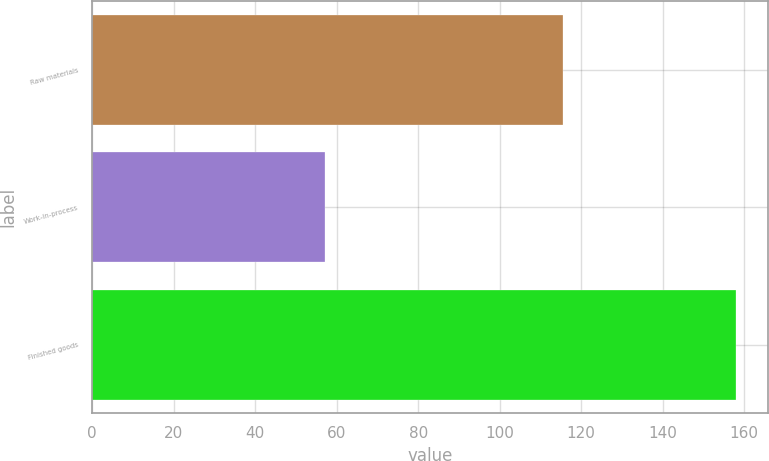<chart> <loc_0><loc_0><loc_500><loc_500><bar_chart><fcel>Raw materials<fcel>Work-in-process<fcel>Finished goods<nl><fcel>115.6<fcel>57.1<fcel>157.9<nl></chart> 